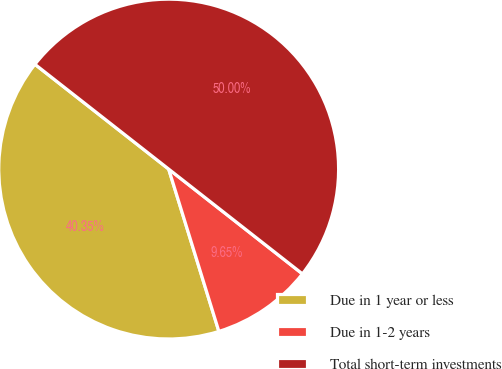Convert chart. <chart><loc_0><loc_0><loc_500><loc_500><pie_chart><fcel>Due in 1 year or less<fcel>Due in 1-2 years<fcel>Total short-term investments<nl><fcel>40.35%<fcel>9.65%<fcel>50.0%<nl></chart> 